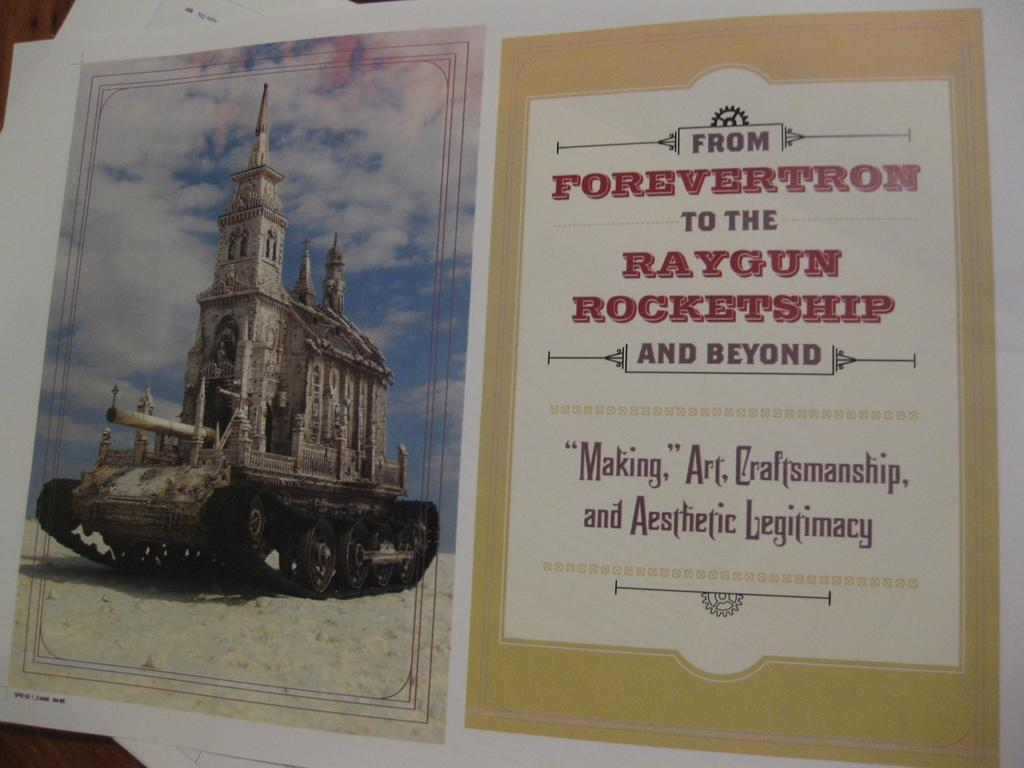<image>
Describe the image concisely. A card from " Foreverton To The Raygun Rocketship and Beyond" with a picture of a tank. 